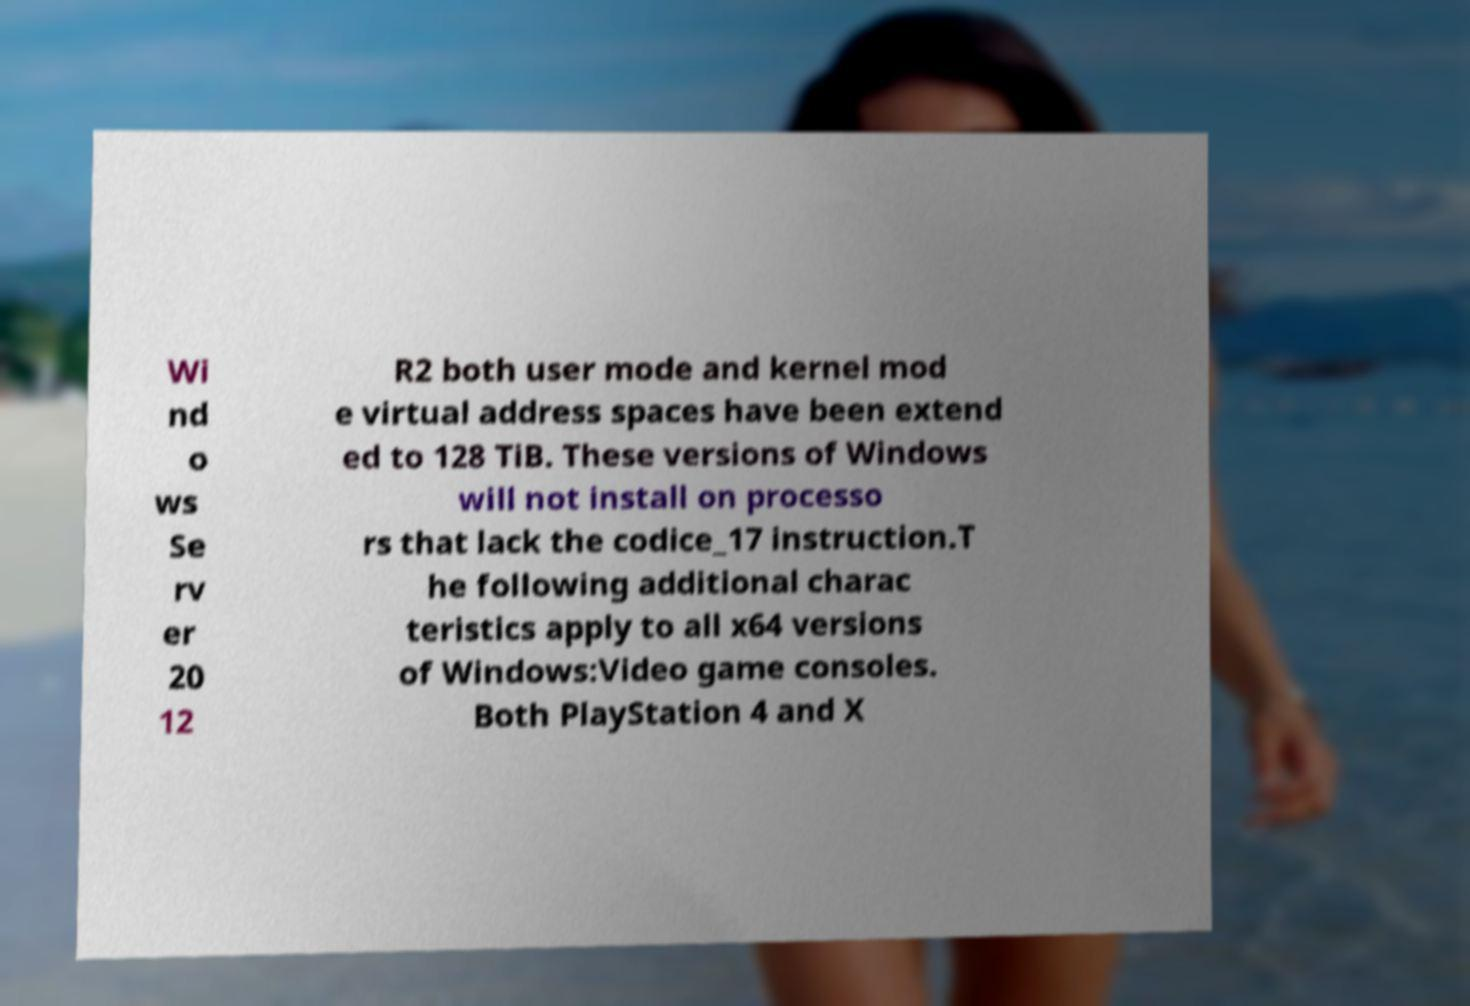Can you accurately transcribe the text from the provided image for me? Wi nd o ws Se rv er 20 12 R2 both user mode and kernel mod e virtual address spaces have been extend ed to 128 TiB. These versions of Windows will not install on processo rs that lack the codice_17 instruction.T he following additional charac teristics apply to all x64 versions of Windows:Video game consoles. Both PlayStation 4 and X 